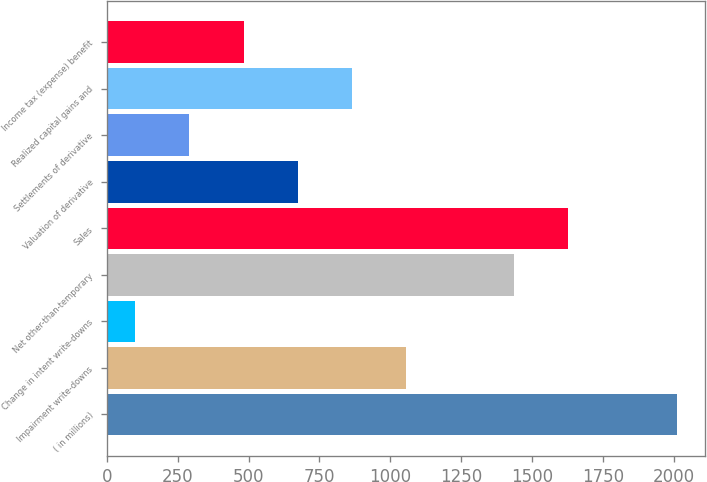Convert chart. <chart><loc_0><loc_0><loc_500><loc_500><bar_chart><fcel>( in millions)<fcel>Impairment write-downs<fcel>Change in intent write-downs<fcel>Net other-than-temporary<fcel>Sales<fcel>Valuation of derivative<fcel>Settlements of derivative<fcel>Realized capital gains and<fcel>Income tax (expense) benefit<nl><fcel>2011<fcel>1055.5<fcel>100<fcel>1437.7<fcel>1628.8<fcel>673.3<fcel>291.1<fcel>864.4<fcel>482.2<nl></chart> 